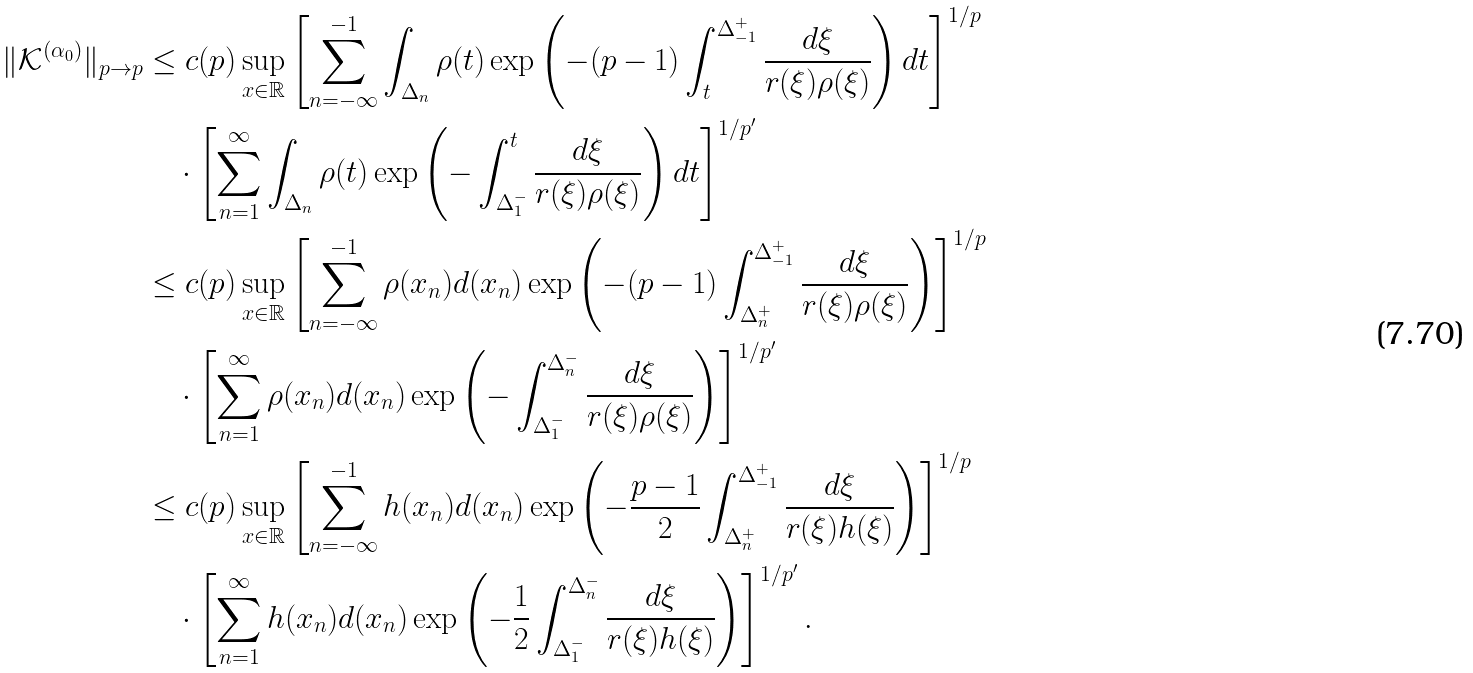<formula> <loc_0><loc_0><loc_500><loc_500>\| \mathcal { K } ^ { ( \alpha _ { 0 } ) } \| _ { p \to p } & \leq c ( p ) \sup _ { x \in \mathbb { R } } \left [ \sum _ { n = - \infty } ^ { - 1 } \int _ { \Delta _ { n } } \rho ( t ) \exp \left ( - ( p - 1 ) \int _ { t } ^ { \Delta _ { - 1 } ^ { + } } \frac { d \xi } { r ( \xi ) \rho ( \xi ) } \right ) d t \right ] ^ { 1 / p } \\ & \quad \cdot \left [ \sum _ { n = 1 } ^ { \infty } \int _ { \Delta _ { n } } \rho ( t ) \exp \left ( - \int _ { \Delta _ { 1 } ^ { - } } ^ { t } \frac { d \xi } { r ( \xi ) \rho ( \xi ) } \right ) d t \right ] ^ { 1 / p ^ { \prime } } \\ & \leq c ( p ) \sup _ { x \in \mathbb { R } } \left [ \sum _ { n = - \infty } ^ { - 1 } \rho ( x _ { n } ) d ( x _ { n } ) \exp \left ( - ( p - 1 ) \int _ { \Delta _ { n } ^ { + } } ^ { \Delta _ { - 1 } ^ { + } } \frac { d \xi } { r ( \xi ) \rho ( \xi ) } \right ) \right ] ^ { 1 / p } \\ & \quad \cdot \left [ \sum _ { n = 1 } ^ { \infty } \rho ( x _ { n } ) d ( x _ { n } ) \exp \left ( - \int _ { \Delta _ { 1 } ^ { - } } ^ { \Delta _ { n } ^ { - } } \frac { d \xi } { r ( \xi ) \rho ( \xi ) } \right ) \right ] ^ { 1 / p ^ { \prime } } \\ & \leq c ( p ) \sup _ { x \in \mathbb { R } } \left [ \sum _ { n = - \infty } ^ { - 1 } h ( x _ { n } ) d ( x _ { n } ) \exp \left ( - \frac { p - 1 } { 2 } \int _ { \Delta _ { n } ^ { + } } ^ { \Delta _ { - 1 } ^ { + } } \frac { d \xi } { r ( \xi ) h ( \xi ) } \right ) \right ] ^ { 1 / p } \\ & \quad \cdot \left [ \sum _ { n = 1 } ^ { \infty } h ( x _ { n } ) d ( x _ { n } ) \exp \left ( - \frac { 1 } { 2 } \int _ { \Delta _ { 1 } ^ { - } } ^ { \Delta _ { n } ^ { - } } \frac { d \xi } { r ( \xi ) h ( \xi ) } \right ) \right ] ^ { 1 / p ^ { \prime } } .</formula> 